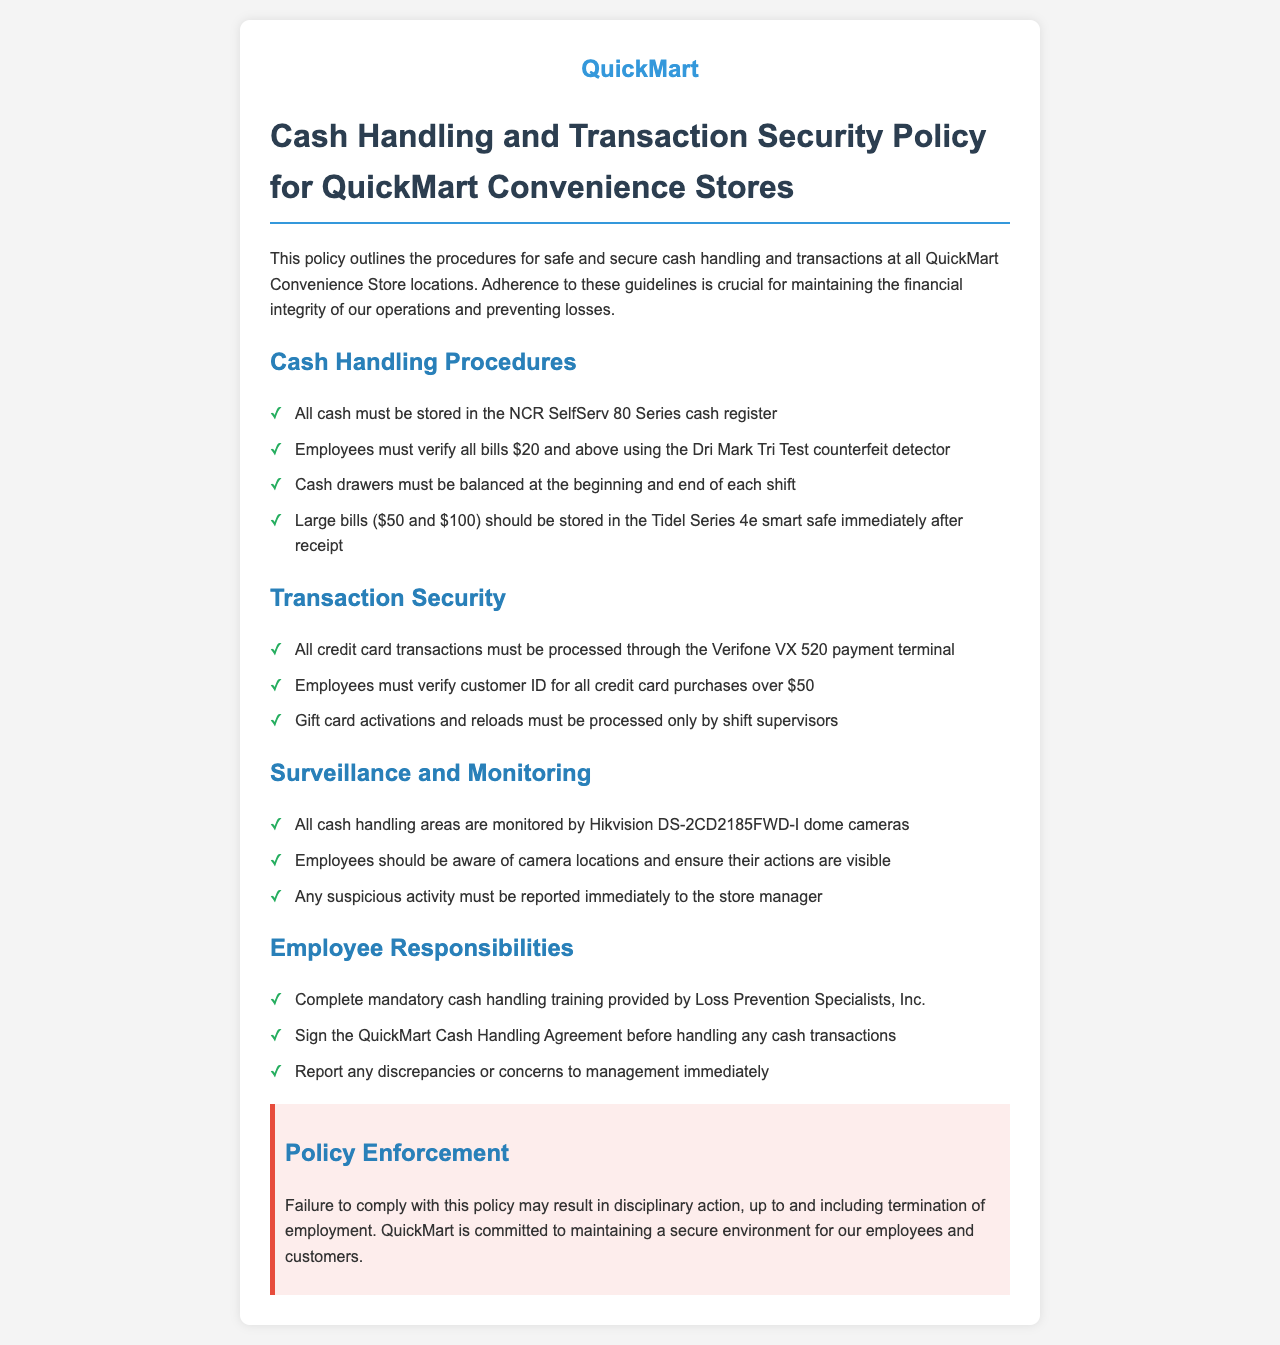what is the model of the cash register? The cash register model required for cash storage is mentioned in the document.
Answer: NCR SelfServ 80 Series how should large bills be stored? The document specifies the procedure for handling large bills immediately after receipt.
Answer: Tidel Series 4e smart safe who is responsible for processing gift card transactions? The document indicates which employees are allowed to process gift card activations and reloads.
Answer: shift supervisors what type of camera is used for monitoring cash handling areas? The specific model of the surveillance camera is identified within the policy.
Answer: Hikvision DS-2CD2185FWD-I what is the consequence for failing to comply with the policy? The document outlines the potential disciplinary measures for policy non-compliance.
Answer: termination of employment which device is used for processing credit card transactions? The policy mentions the payment terminal designated for credit card transactions.
Answer: Verifone VX 520 what must employees do before handling cash transactions? The document states a requirement employees must fulfill regarding cash handling.
Answer: sign the QuickMart Cash Handling Agreement how often must cash drawers be balanced? This query relates to the frequency of a specific task mentioned in the policy.
Answer: at the beginning and end of each shift 